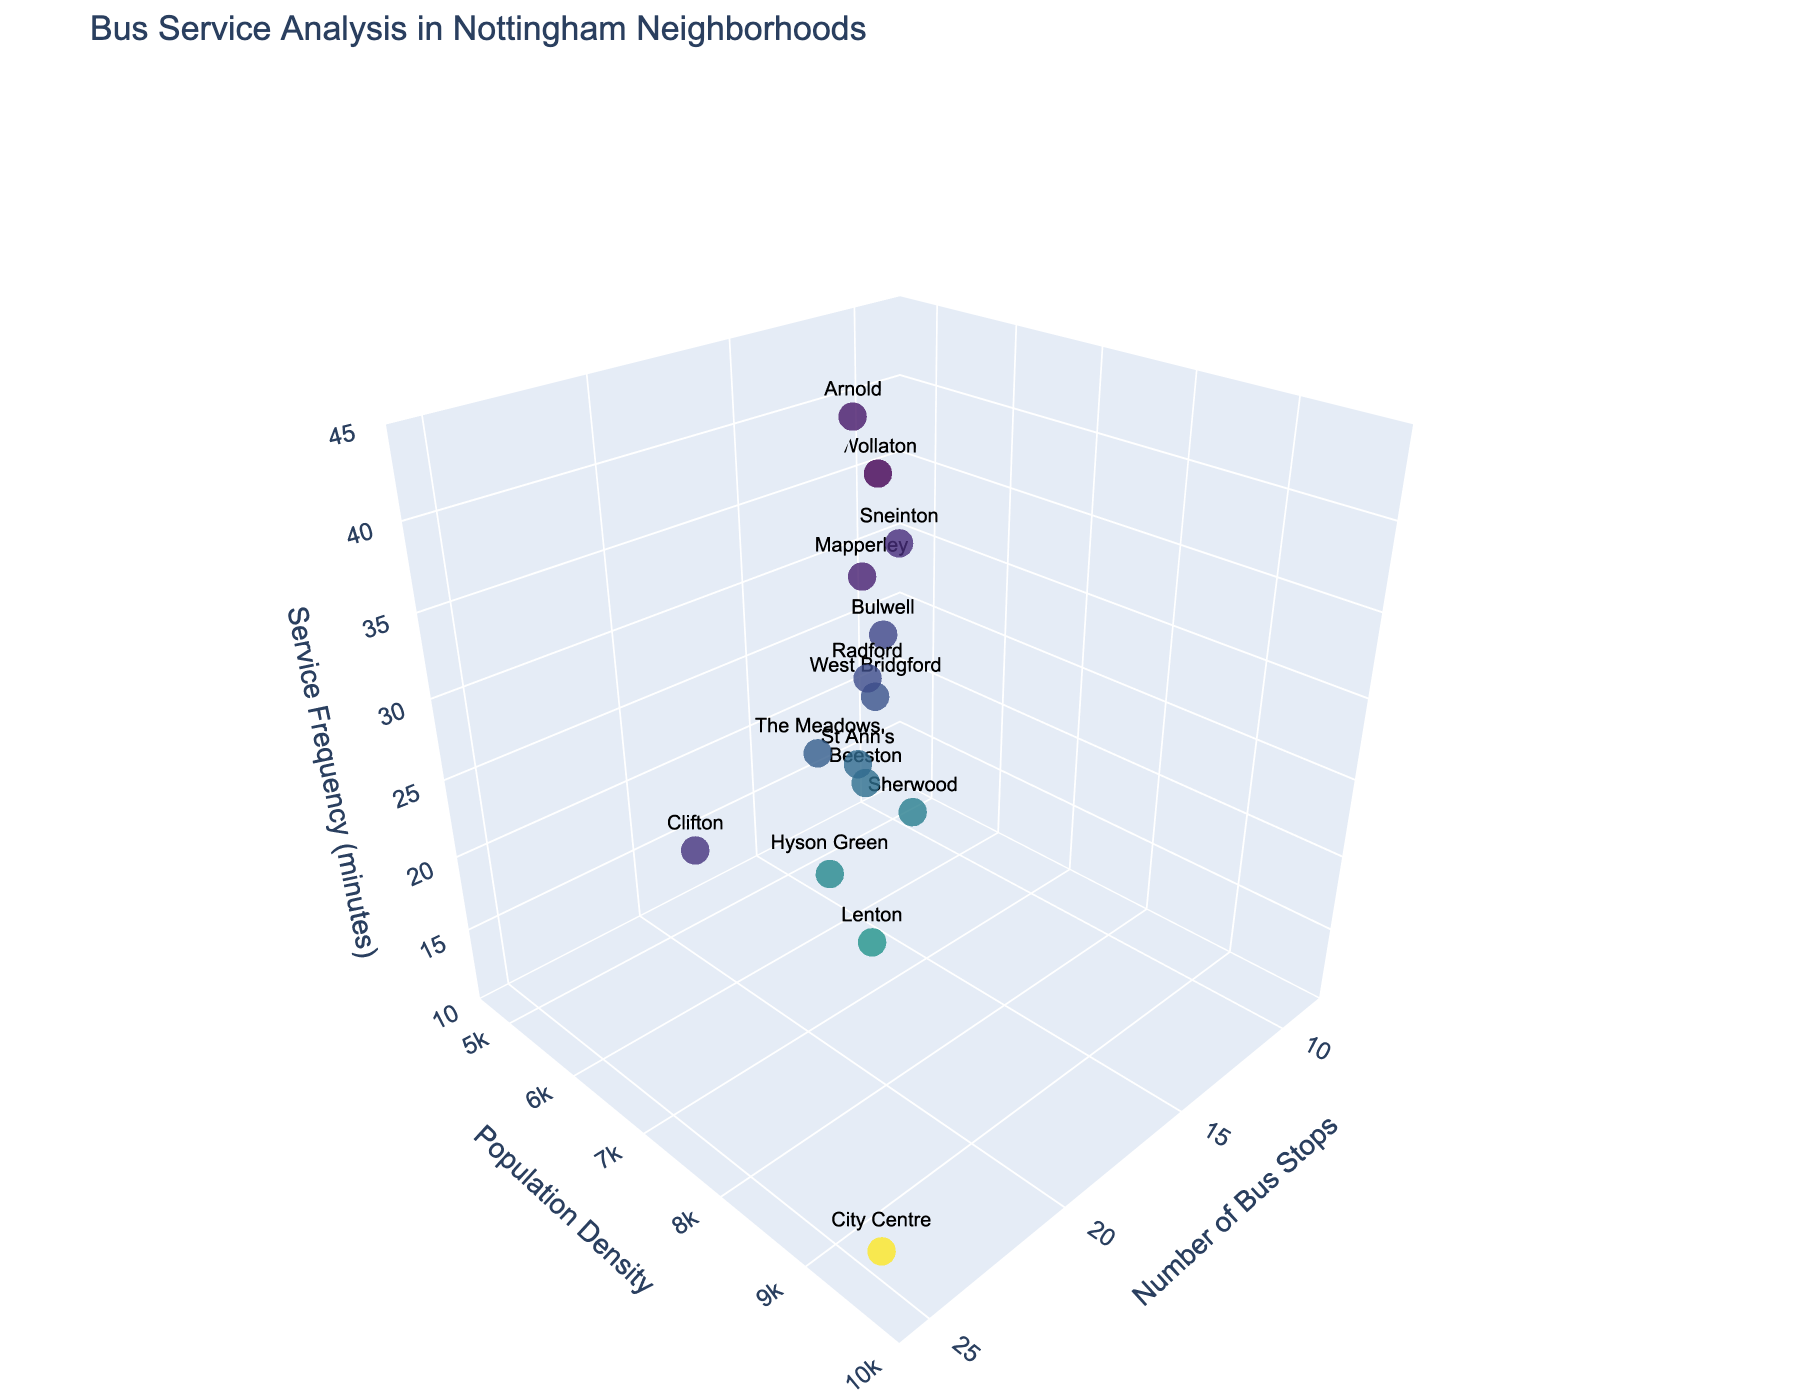What's the title of the figure? The title of the figure is usually displayed at the top and summarizes the content of the visual representation. In this case, it covers the analysis of bus services in Nottingham neighborhoods.
Answer: Bus Service Analysis in Nottingham Neighborhoods How many neighborhoods are represented in the plot? Each data point represents a neighborhood. Counting the data points provides the answer.
Answer: 15 Which neighborhood has the highest population density? Locate the point with the highest value on the Population Density axis. The associated neighborhood label tells us which one it is.
Answer: City Centre In which neighborhood is the frequency of bus service the lowest? To identify the neighborhood with the lowest frequency, locate the point with the highest value on the Service Frequency axis (since a higher number means a lower frequency).
Answer: Arnold What is the bus service frequency in Lenton? Find the data point labeled Lenton and look at its position on the Service Frequency axis.
Answer: 15 minutes Compare the number of bus stops in Sherwood and Clifton. Which has more, and by how many? Identify the positions of Sherwood and Clifton along the Bus Stops axis and calculate the difference. Sherwood: 15, Clifton: 20. The difference is 20 - 15.
Answer: Clifton has 5 more bus stops What's the combined service frequency for Sneinton and Radford? Find the service frequencies for Sneinton (32) and Radford (26), and then add them together.
Answer: 58 Which neighborhood has fewer bus stops, Mapperley or The Meadows, and how many fewer? Compare the bus stops in Mapperley (12) and The Meadows (17). Subtract the smaller value from the larger one.
Answer: Mapperley has 5 fewer bus stops If you were to live in a neighborhood with at least 7000 population density and more than 15 bus stops, which neighborhoods could you choose from? Look for neighborhoods where Population Density ≥ 7000 and Bus Stops > 15. Hyson Green has 19 bus stops and 7000 population density. Lenton has 18 bus stops and 7200 population density.
Answer: Hyson Green and Lenton Does a higher population density always correlate with more bus stops in Nottingham neighborhoods? Observe the scatter plot to see if points with higher population densities consistently align with more bus stops. This involves looking for a general trend rather than an exact correlation.
Answer: No 